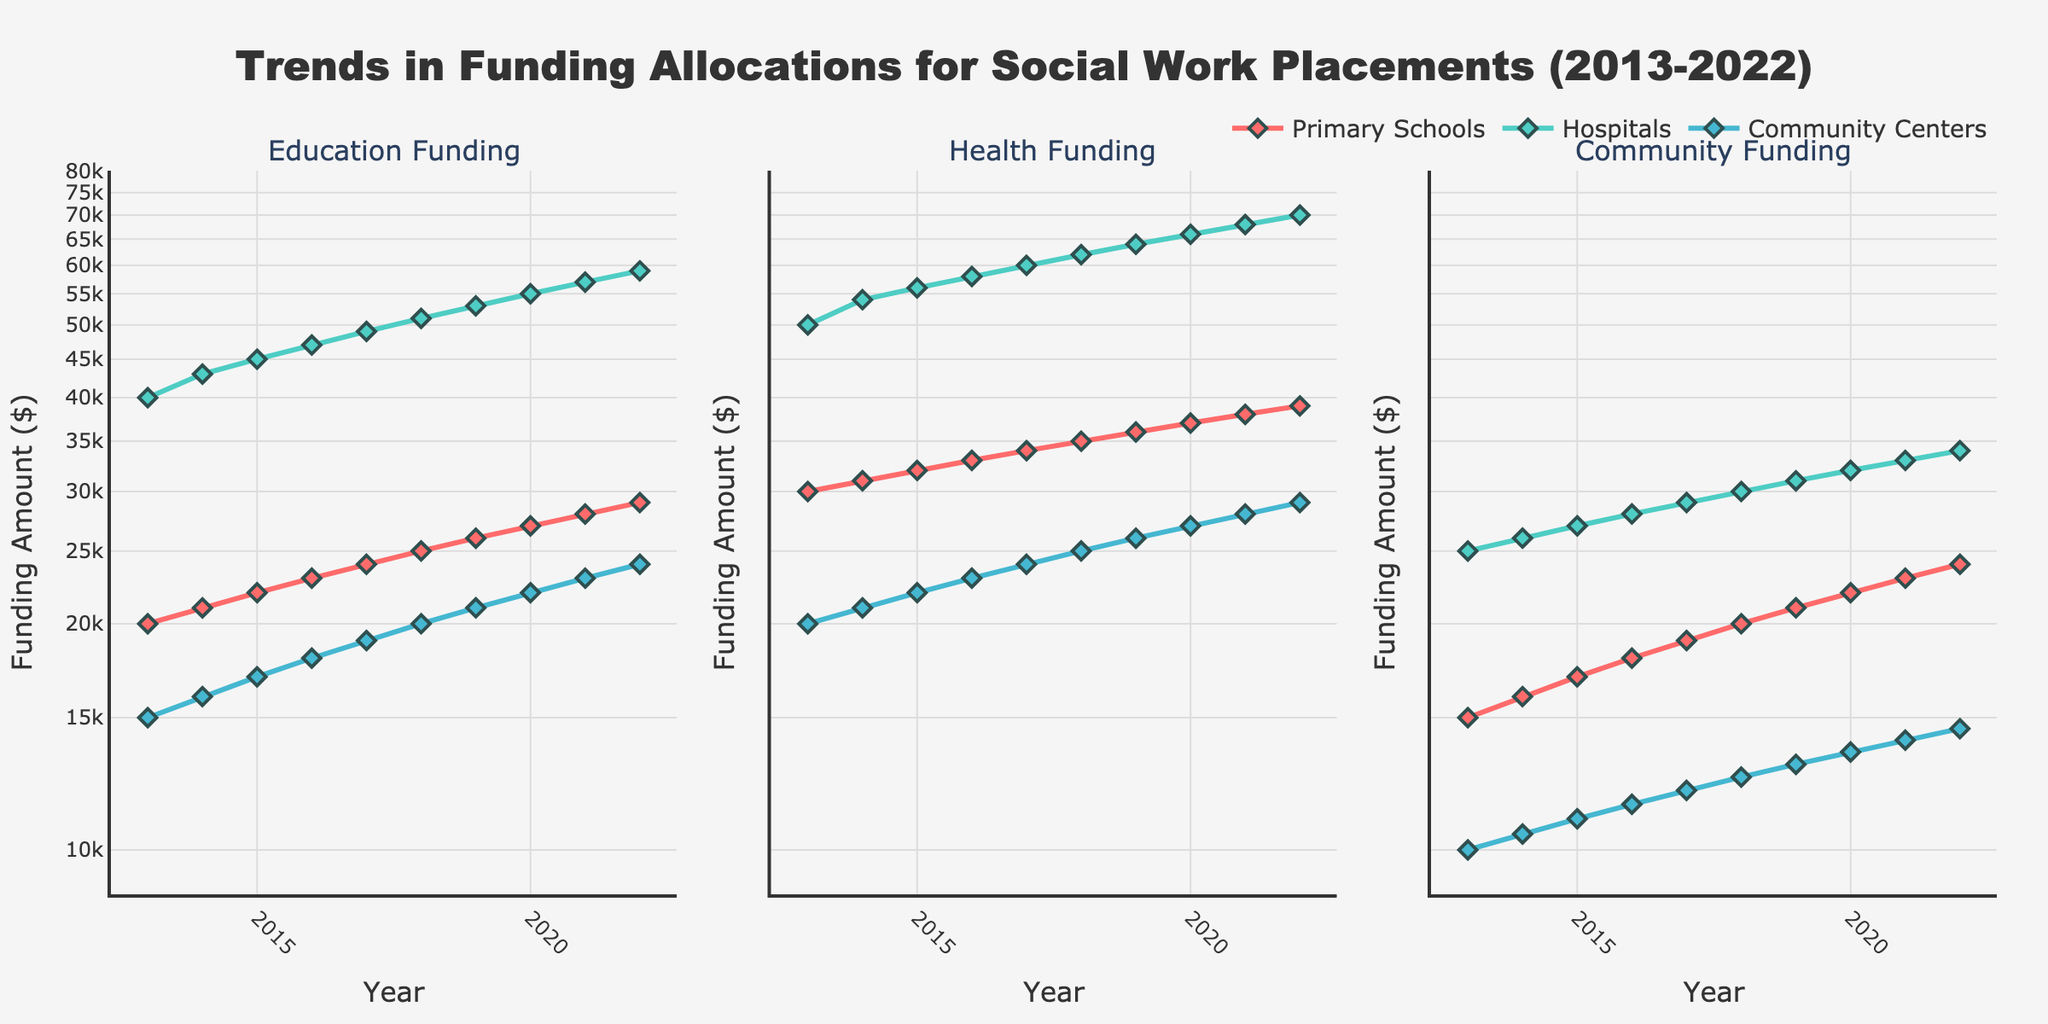What is the title of the figure? The title is displayed at the top center of the figure, which describes the content being visualized.
Answer: Trends in Funding Allocations for Social Work Placements (2013-2022) How many placement types are represented in the figure? There are three unique placement types represented by different lines and markers across the subplots. They are visible through the legend and colored lines for each subplot.
Answer: 3 Which placement type had the highest Health Funding in 2020? Locate the "Health Funding" subplot, find the year 2020 on the x-axis, and identify the highest value marker among the three placement types. Hospitals have the highest funding in Health Funding in 2020.
Answer: Hospitals What is the trend of Education Funding for Primary Schools from 2013 to 2022? In the "Education Funding" subplot, follow the line that represents Primary Schools from 2013 to 2022. The trend is upward, as the funding amount increases each year.
Answer: Increasing Compare the Community Funding trends for Hospitals and Community Centers between 2013 and 2022. In the "Community Funding" subplot, trace the lines representing Hospitals and Community Centers from 2013 to 2022. Hospitals show a consistently higher amount and a faster growth rate compared to Community Centers.
Answer: Hospitals have higher and faster-growing funding Which funding type shows the most significant increase for Community Centers from 2013 to 2022? Examine the three subplots, focusing on the trend lines for Community Centers. Identify which plot has the steepest upward slope for Community Centers from 2013 to 2022.
Answer: Education Funding Are there any years where the funding amounts in all three categories are the same for any placement type? Check each subplot for overlapping points vertically corresponding to any specific year for any given placement type. No such overlaps suggest equal funding amounts across the three categories for the same year.
Answer: No What is the average Health Funding for Hospitals between 2013 and 2022? Summarize the Health Funding amounts for Hospitals from each year, and divide by the number of years. Amounts are: 50000, 54000, 56000, 58000, 60000, 62000, 64000, 66000, 68000, 70000. Their sum is 608000. Divide this by 10 years.
Answer: 60800 